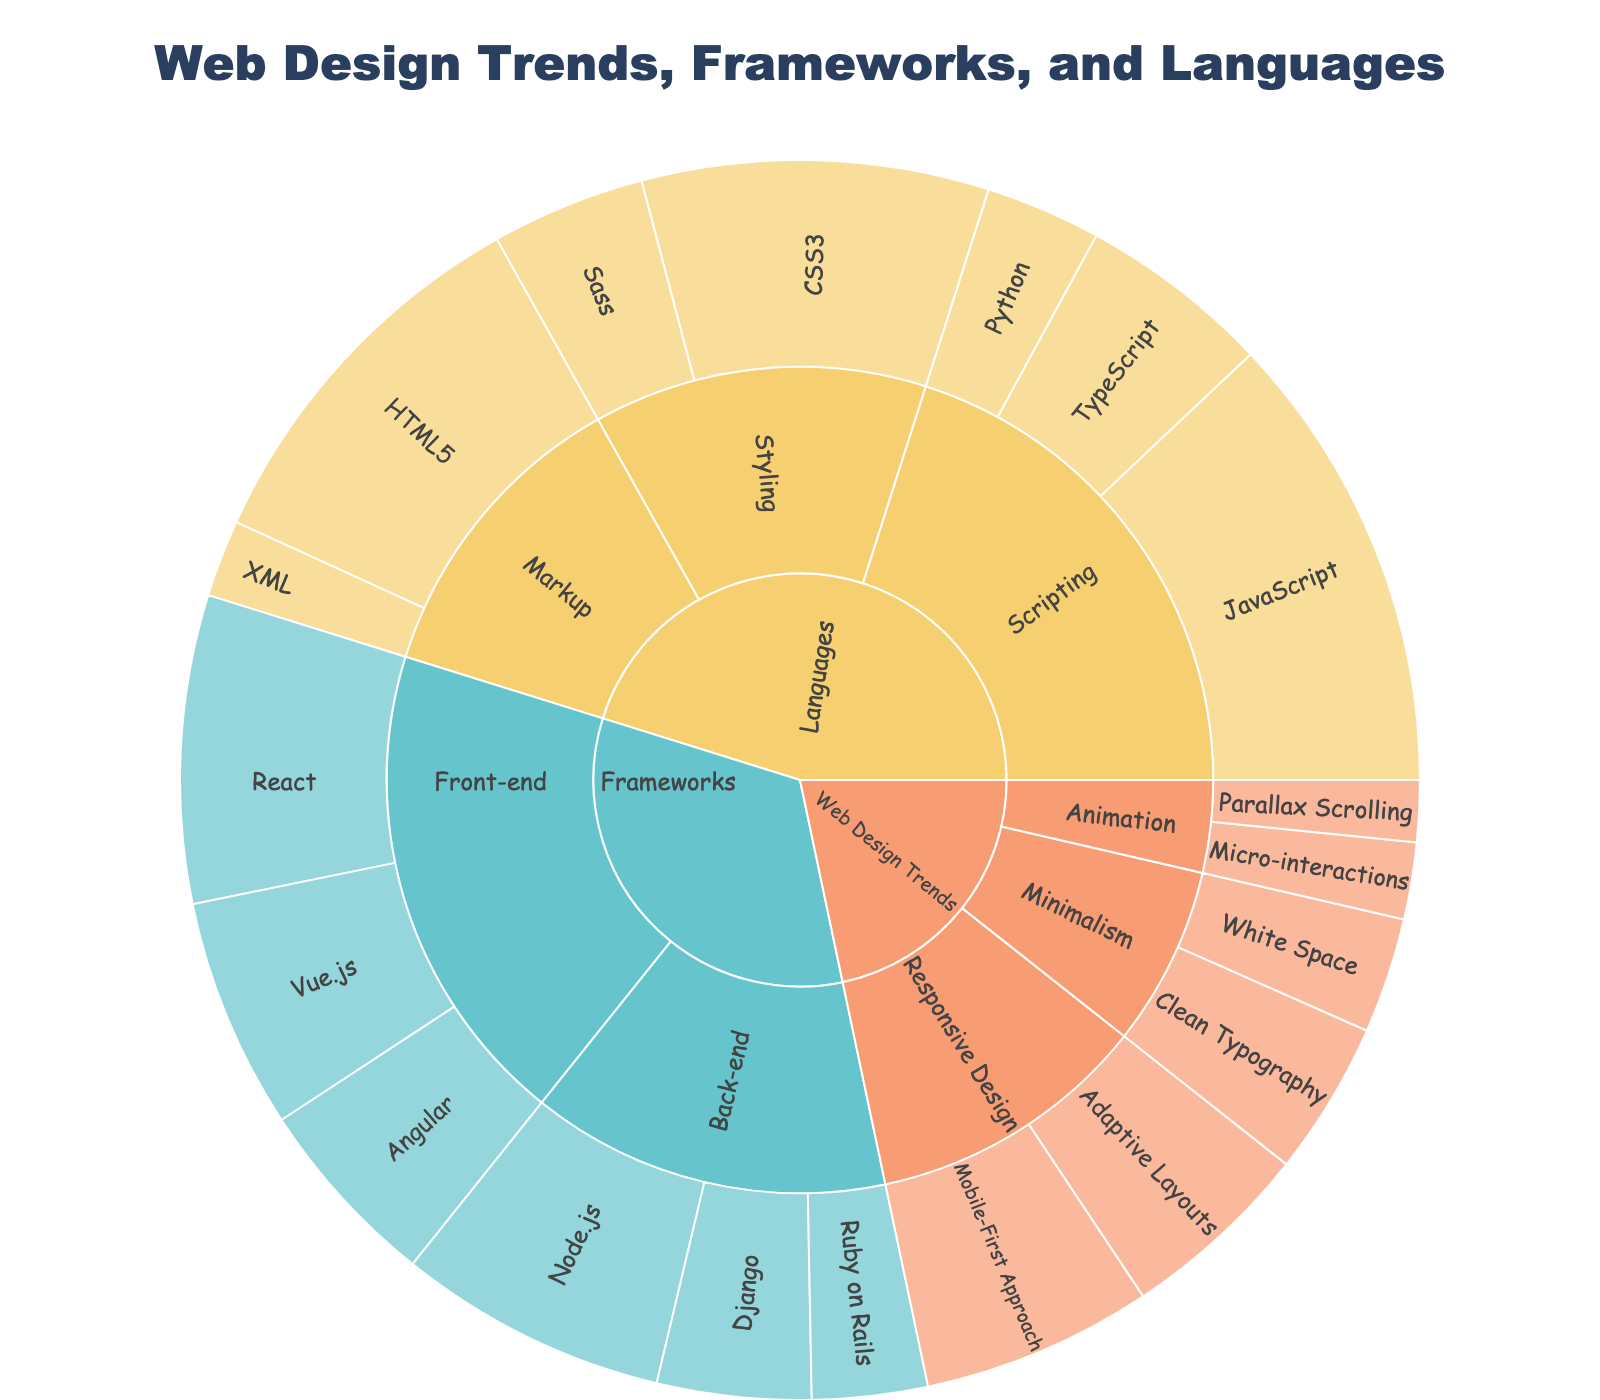What's the title of the sunburst plot? The title is located at the top center of the figure, usually in a large font size, making it easy to identify.
Answer: Web Design Trends, Frameworks, and Languages What is the most popular front-end framework? To determine the most popular front-end framework, look for the subcategory 'Front-end' under the main category 'Frameworks'. Identify the item with the largest value in this subcategory.
Answer: React What is the total value for Responsive Design under Web Design Trends? To find the total value for Responsive Design, sum the values of its items (Mobile-First Approach and Adaptive Layouts). The values are 30 and 25, respectively.
Answer: 55 Which language has the highest value and how much is it? Look under the 'Languages' category and identify the item with the highest value among all subcategories.
Answer: JavaScript, 60 By how much does the most popular styling language exceed Sass? Find the most popular styling language under 'Languages > Styling' and subtract the value of Sass from it. From the values listed, CSS3 is the most popular with a value of 45. Subtract 20 (Sass) from 45.
Answer: 25 Under the category Minimalism, which item has the lowest value? Look into the Minimalism subcategory under Web Design Trends and identify the item with the lower value by comparing 'Clean Typography' and 'White Space'.
Answer: White Space Which has a higher total value: Front-end frameworks or Back-end frameworks? Add up the values of all front-end frameworks (React, Vue.js, Angular) and compare the sum with the total values for back-end frameworks (Node.js, Django, Ruby on Rails). Front-end frameworks total to 95 (40 + 30 + 25), and back-end to 70 (35 + 20 + 15).
Answer: Front-end frameworks What's the combined value of all items under the Web Design Trends category? Add all of the values under each subcategory (Responsive Design, Minimalism, Animation) within Web Design Trends. 30+25+20+15+10+8
Answer: 108 